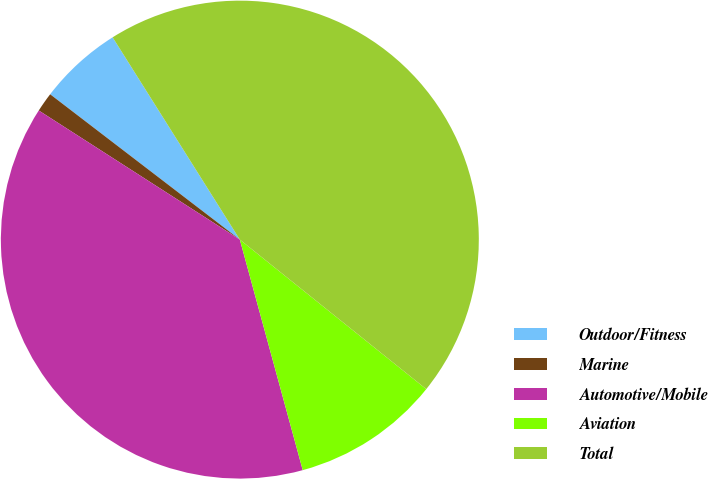<chart> <loc_0><loc_0><loc_500><loc_500><pie_chart><fcel>Outdoor/Fitness<fcel>Marine<fcel>Automotive/Mobile<fcel>Aviation<fcel>Total<nl><fcel>5.66%<fcel>1.32%<fcel>38.32%<fcel>10.0%<fcel>44.69%<nl></chart> 